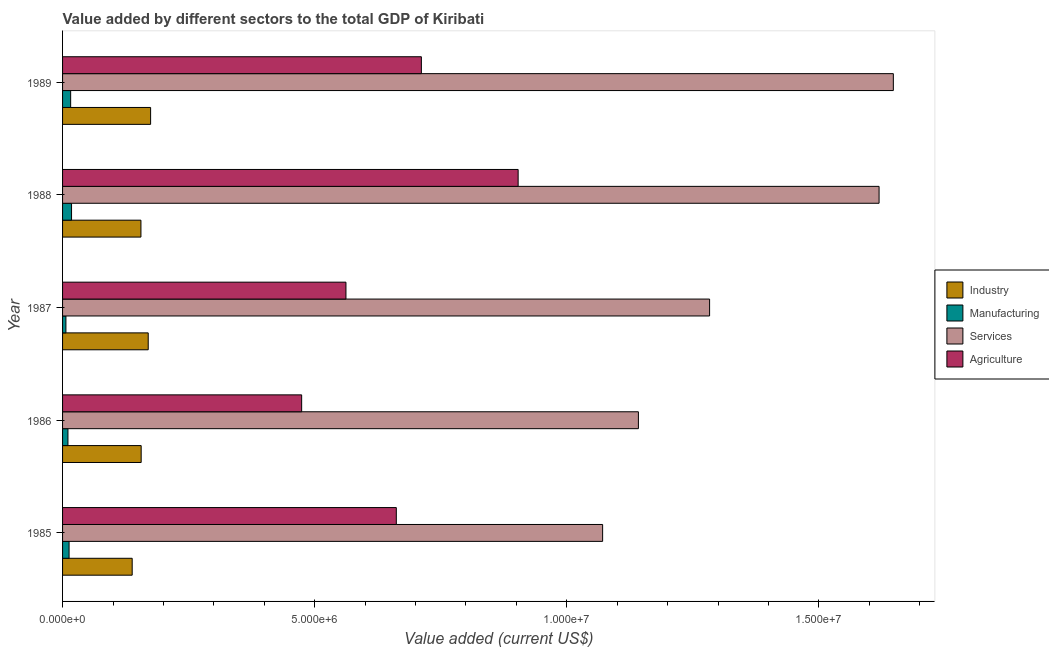How many bars are there on the 1st tick from the top?
Keep it short and to the point. 4. How many bars are there on the 5th tick from the bottom?
Make the answer very short. 4. What is the value added by manufacturing sector in 1989?
Keep it short and to the point. 1.61e+05. Across all years, what is the maximum value added by services sector?
Ensure brevity in your answer.  1.65e+07. Across all years, what is the minimum value added by services sector?
Keep it short and to the point. 1.07e+07. In which year was the value added by agricultural sector maximum?
Ensure brevity in your answer.  1988. What is the total value added by agricultural sector in the graph?
Your answer should be very brief. 3.31e+07. What is the difference between the value added by manufacturing sector in 1987 and that in 1988?
Your response must be concise. -1.12e+05. What is the difference between the value added by agricultural sector in 1988 and the value added by industrial sector in 1985?
Offer a very short reply. 7.65e+06. What is the average value added by agricultural sector per year?
Your answer should be very brief. 6.63e+06. In the year 1987, what is the difference between the value added by manufacturing sector and value added by industrial sector?
Offer a terse response. -1.63e+06. In how many years, is the value added by agricultural sector greater than 3000000 US$?
Your answer should be compact. 5. What is the ratio of the value added by services sector in 1985 to that in 1989?
Provide a succinct answer. 0.65. Is the difference between the value added by services sector in 1986 and 1989 greater than the difference between the value added by agricultural sector in 1986 and 1989?
Offer a terse response. No. What is the difference between the highest and the second highest value added by manufacturing sector?
Keep it short and to the point. 1.76e+04. What is the difference between the highest and the lowest value added by services sector?
Give a very brief answer. 5.77e+06. In how many years, is the value added by industrial sector greater than the average value added by industrial sector taken over all years?
Offer a very short reply. 2. Is the sum of the value added by manufacturing sector in 1985 and 1988 greater than the maximum value added by agricultural sector across all years?
Your response must be concise. No. Is it the case that in every year, the sum of the value added by agricultural sector and value added by services sector is greater than the sum of value added by industrial sector and value added by manufacturing sector?
Your answer should be very brief. Yes. What does the 1st bar from the top in 1988 represents?
Provide a succinct answer. Agriculture. What does the 2nd bar from the bottom in 1989 represents?
Offer a very short reply. Manufacturing. How many bars are there?
Your answer should be compact. 20. How many years are there in the graph?
Make the answer very short. 5. Are the values on the major ticks of X-axis written in scientific E-notation?
Give a very brief answer. Yes. Does the graph contain any zero values?
Give a very brief answer. No. Does the graph contain grids?
Offer a very short reply. No. Where does the legend appear in the graph?
Keep it short and to the point. Center right. How many legend labels are there?
Provide a short and direct response. 4. How are the legend labels stacked?
Ensure brevity in your answer.  Vertical. What is the title of the graph?
Your response must be concise. Value added by different sectors to the total GDP of Kiribati. Does "France" appear as one of the legend labels in the graph?
Your response must be concise. No. What is the label or title of the X-axis?
Offer a very short reply. Value added (current US$). What is the label or title of the Y-axis?
Provide a succinct answer. Year. What is the Value added (current US$) in Industry in 1985?
Keep it short and to the point. 1.38e+06. What is the Value added (current US$) in Manufacturing in 1985?
Provide a short and direct response. 1.29e+05. What is the Value added (current US$) of Services in 1985?
Offer a terse response. 1.07e+07. What is the Value added (current US$) of Agriculture in 1985?
Provide a short and direct response. 6.62e+06. What is the Value added (current US$) of Industry in 1986?
Your answer should be compact. 1.56e+06. What is the Value added (current US$) of Manufacturing in 1986?
Give a very brief answer. 1.07e+05. What is the Value added (current US$) in Services in 1986?
Ensure brevity in your answer.  1.14e+07. What is the Value added (current US$) of Agriculture in 1986?
Offer a terse response. 4.74e+06. What is the Value added (current US$) of Industry in 1987?
Keep it short and to the point. 1.70e+06. What is the Value added (current US$) of Manufacturing in 1987?
Keep it short and to the point. 6.65e+04. What is the Value added (current US$) of Services in 1987?
Keep it short and to the point. 1.28e+07. What is the Value added (current US$) in Agriculture in 1987?
Provide a short and direct response. 5.62e+06. What is the Value added (current US$) of Industry in 1988?
Your response must be concise. 1.55e+06. What is the Value added (current US$) in Manufacturing in 1988?
Ensure brevity in your answer.  1.78e+05. What is the Value added (current US$) of Services in 1988?
Your answer should be very brief. 1.62e+07. What is the Value added (current US$) of Agriculture in 1988?
Provide a succinct answer. 9.03e+06. What is the Value added (current US$) of Industry in 1989?
Your answer should be compact. 1.75e+06. What is the Value added (current US$) in Manufacturing in 1989?
Keep it short and to the point. 1.61e+05. What is the Value added (current US$) in Services in 1989?
Ensure brevity in your answer.  1.65e+07. What is the Value added (current US$) of Agriculture in 1989?
Your response must be concise. 7.12e+06. Across all years, what is the maximum Value added (current US$) of Industry?
Give a very brief answer. 1.75e+06. Across all years, what is the maximum Value added (current US$) in Manufacturing?
Your answer should be compact. 1.78e+05. Across all years, what is the maximum Value added (current US$) in Services?
Give a very brief answer. 1.65e+07. Across all years, what is the maximum Value added (current US$) in Agriculture?
Offer a very short reply. 9.03e+06. Across all years, what is the minimum Value added (current US$) in Industry?
Provide a short and direct response. 1.38e+06. Across all years, what is the minimum Value added (current US$) of Manufacturing?
Your response must be concise. 6.65e+04. Across all years, what is the minimum Value added (current US$) of Services?
Your response must be concise. 1.07e+07. Across all years, what is the minimum Value added (current US$) in Agriculture?
Provide a succinct answer. 4.74e+06. What is the total Value added (current US$) of Industry in the graph?
Your answer should be compact. 7.94e+06. What is the total Value added (current US$) in Manufacturing in the graph?
Provide a succinct answer. 6.41e+05. What is the total Value added (current US$) in Services in the graph?
Give a very brief answer. 6.76e+07. What is the total Value added (current US$) in Agriculture in the graph?
Keep it short and to the point. 3.31e+07. What is the difference between the Value added (current US$) of Industry in 1985 and that in 1986?
Your answer should be compact. -1.78e+05. What is the difference between the Value added (current US$) in Manufacturing in 1985 and that in 1986?
Your answer should be compact. 2.22e+04. What is the difference between the Value added (current US$) in Services in 1985 and that in 1986?
Ensure brevity in your answer.  -7.10e+05. What is the difference between the Value added (current US$) in Agriculture in 1985 and that in 1986?
Your response must be concise. 1.88e+06. What is the difference between the Value added (current US$) of Industry in 1985 and that in 1987?
Make the answer very short. -3.18e+05. What is the difference between the Value added (current US$) of Manufacturing in 1985 and that in 1987?
Provide a short and direct response. 6.27e+04. What is the difference between the Value added (current US$) of Services in 1985 and that in 1987?
Offer a very short reply. -2.12e+06. What is the difference between the Value added (current US$) of Agriculture in 1985 and that in 1987?
Make the answer very short. 9.99e+05. What is the difference between the Value added (current US$) of Industry in 1985 and that in 1988?
Offer a terse response. -1.73e+05. What is the difference between the Value added (current US$) of Manufacturing in 1985 and that in 1988?
Your response must be concise. -4.89e+04. What is the difference between the Value added (current US$) of Services in 1985 and that in 1988?
Offer a terse response. -5.48e+06. What is the difference between the Value added (current US$) of Agriculture in 1985 and that in 1988?
Give a very brief answer. -2.42e+06. What is the difference between the Value added (current US$) of Industry in 1985 and that in 1989?
Your answer should be compact. -3.65e+05. What is the difference between the Value added (current US$) in Manufacturing in 1985 and that in 1989?
Provide a short and direct response. -3.13e+04. What is the difference between the Value added (current US$) in Services in 1985 and that in 1989?
Keep it short and to the point. -5.77e+06. What is the difference between the Value added (current US$) in Agriculture in 1985 and that in 1989?
Your response must be concise. -4.97e+05. What is the difference between the Value added (current US$) in Industry in 1986 and that in 1987?
Your response must be concise. -1.40e+05. What is the difference between the Value added (current US$) of Manufacturing in 1986 and that in 1987?
Your answer should be very brief. 4.04e+04. What is the difference between the Value added (current US$) in Services in 1986 and that in 1987?
Provide a short and direct response. -1.41e+06. What is the difference between the Value added (current US$) in Agriculture in 1986 and that in 1987?
Ensure brevity in your answer.  -8.78e+05. What is the difference between the Value added (current US$) of Industry in 1986 and that in 1988?
Your answer should be compact. 4795.87. What is the difference between the Value added (current US$) in Manufacturing in 1986 and that in 1988?
Your answer should be very brief. -7.12e+04. What is the difference between the Value added (current US$) of Services in 1986 and that in 1988?
Your answer should be compact. -4.77e+06. What is the difference between the Value added (current US$) in Agriculture in 1986 and that in 1988?
Offer a terse response. -4.29e+06. What is the difference between the Value added (current US$) of Industry in 1986 and that in 1989?
Your response must be concise. -1.87e+05. What is the difference between the Value added (current US$) of Manufacturing in 1986 and that in 1989?
Provide a short and direct response. -5.36e+04. What is the difference between the Value added (current US$) of Services in 1986 and that in 1989?
Your answer should be compact. -5.06e+06. What is the difference between the Value added (current US$) in Agriculture in 1986 and that in 1989?
Offer a very short reply. -2.37e+06. What is the difference between the Value added (current US$) of Industry in 1987 and that in 1988?
Make the answer very short. 1.45e+05. What is the difference between the Value added (current US$) in Manufacturing in 1987 and that in 1988?
Make the answer very short. -1.12e+05. What is the difference between the Value added (current US$) of Services in 1987 and that in 1988?
Provide a short and direct response. -3.36e+06. What is the difference between the Value added (current US$) of Agriculture in 1987 and that in 1988?
Your answer should be compact. -3.41e+06. What is the difference between the Value added (current US$) of Industry in 1987 and that in 1989?
Your answer should be compact. -4.74e+04. What is the difference between the Value added (current US$) of Manufacturing in 1987 and that in 1989?
Provide a short and direct response. -9.40e+04. What is the difference between the Value added (current US$) in Services in 1987 and that in 1989?
Ensure brevity in your answer.  -3.64e+06. What is the difference between the Value added (current US$) of Agriculture in 1987 and that in 1989?
Your response must be concise. -1.50e+06. What is the difference between the Value added (current US$) in Industry in 1988 and that in 1989?
Your answer should be compact. -1.92e+05. What is the difference between the Value added (current US$) of Manufacturing in 1988 and that in 1989?
Give a very brief answer. 1.76e+04. What is the difference between the Value added (current US$) in Services in 1988 and that in 1989?
Make the answer very short. -2.83e+05. What is the difference between the Value added (current US$) of Agriculture in 1988 and that in 1989?
Provide a succinct answer. 1.92e+06. What is the difference between the Value added (current US$) in Industry in 1985 and the Value added (current US$) in Manufacturing in 1986?
Offer a very short reply. 1.27e+06. What is the difference between the Value added (current US$) in Industry in 1985 and the Value added (current US$) in Services in 1986?
Your response must be concise. -1.00e+07. What is the difference between the Value added (current US$) in Industry in 1985 and the Value added (current US$) in Agriculture in 1986?
Provide a short and direct response. -3.36e+06. What is the difference between the Value added (current US$) of Manufacturing in 1985 and the Value added (current US$) of Services in 1986?
Offer a terse response. -1.13e+07. What is the difference between the Value added (current US$) of Manufacturing in 1985 and the Value added (current US$) of Agriculture in 1986?
Provide a short and direct response. -4.61e+06. What is the difference between the Value added (current US$) of Services in 1985 and the Value added (current US$) of Agriculture in 1986?
Keep it short and to the point. 5.97e+06. What is the difference between the Value added (current US$) of Industry in 1985 and the Value added (current US$) of Manufacturing in 1987?
Provide a succinct answer. 1.31e+06. What is the difference between the Value added (current US$) in Industry in 1985 and the Value added (current US$) in Services in 1987?
Your answer should be very brief. -1.15e+07. What is the difference between the Value added (current US$) of Industry in 1985 and the Value added (current US$) of Agriculture in 1987?
Your answer should be compact. -4.24e+06. What is the difference between the Value added (current US$) of Manufacturing in 1985 and the Value added (current US$) of Services in 1987?
Your response must be concise. -1.27e+07. What is the difference between the Value added (current US$) of Manufacturing in 1985 and the Value added (current US$) of Agriculture in 1987?
Make the answer very short. -5.49e+06. What is the difference between the Value added (current US$) of Services in 1985 and the Value added (current US$) of Agriculture in 1987?
Your response must be concise. 5.09e+06. What is the difference between the Value added (current US$) in Industry in 1985 and the Value added (current US$) in Manufacturing in 1988?
Provide a succinct answer. 1.20e+06. What is the difference between the Value added (current US$) in Industry in 1985 and the Value added (current US$) in Services in 1988?
Your response must be concise. -1.48e+07. What is the difference between the Value added (current US$) in Industry in 1985 and the Value added (current US$) in Agriculture in 1988?
Ensure brevity in your answer.  -7.65e+06. What is the difference between the Value added (current US$) in Manufacturing in 1985 and the Value added (current US$) in Services in 1988?
Your answer should be very brief. -1.61e+07. What is the difference between the Value added (current US$) in Manufacturing in 1985 and the Value added (current US$) in Agriculture in 1988?
Give a very brief answer. -8.91e+06. What is the difference between the Value added (current US$) of Services in 1985 and the Value added (current US$) of Agriculture in 1988?
Keep it short and to the point. 1.68e+06. What is the difference between the Value added (current US$) of Industry in 1985 and the Value added (current US$) of Manufacturing in 1989?
Your response must be concise. 1.22e+06. What is the difference between the Value added (current US$) of Industry in 1985 and the Value added (current US$) of Services in 1989?
Provide a short and direct response. -1.51e+07. What is the difference between the Value added (current US$) in Industry in 1985 and the Value added (current US$) in Agriculture in 1989?
Give a very brief answer. -5.73e+06. What is the difference between the Value added (current US$) of Manufacturing in 1985 and the Value added (current US$) of Services in 1989?
Give a very brief answer. -1.63e+07. What is the difference between the Value added (current US$) in Manufacturing in 1985 and the Value added (current US$) in Agriculture in 1989?
Make the answer very short. -6.99e+06. What is the difference between the Value added (current US$) in Services in 1985 and the Value added (current US$) in Agriculture in 1989?
Provide a succinct answer. 3.59e+06. What is the difference between the Value added (current US$) in Industry in 1986 and the Value added (current US$) in Manufacturing in 1987?
Provide a short and direct response. 1.49e+06. What is the difference between the Value added (current US$) of Industry in 1986 and the Value added (current US$) of Services in 1987?
Ensure brevity in your answer.  -1.13e+07. What is the difference between the Value added (current US$) of Industry in 1986 and the Value added (current US$) of Agriculture in 1987?
Provide a short and direct response. -4.06e+06. What is the difference between the Value added (current US$) of Manufacturing in 1986 and the Value added (current US$) of Services in 1987?
Your response must be concise. -1.27e+07. What is the difference between the Value added (current US$) of Manufacturing in 1986 and the Value added (current US$) of Agriculture in 1987?
Give a very brief answer. -5.51e+06. What is the difference between the Value added (current US$) in Services in 1986 and the Value added (current US$) in Agriculture in 1987?
Offer a very short reply. 5.80e+06. What is the difference between the Value added (current US$) of Industry in 1986 and the Value added (current US$) of Manufacturing in 1988?
Ensure brevity in your answer.  1.38e+06. What is the difference between the Value added (current US$) of Industry in 1986 and the Value added (current US$) of Services in 1988?
Your answer should be compact. -1.46e+07. What is the difference between the Value added (current US$) in Industry in 1986 and the Value added (current US$) in Agriculture in 1988?
Offer a very short reply. -7.48e+06. What is the difference between the Value added (current US$) of Manufacturing in 1986 and the Value added (current US$) of Services in 1988?
Make the answer very short. -1.61e+07. What is the difference between the Value added (current US$) in Manufacturing in 1986 and the Value added (current US$) in Agriculture in 1988?
Your answer should be very brief. -8.93e+06. What is the difference between the Value added (current US$) in Services in 1986 and the Value added (current US$) in Agriculture in 1988?
Offer a very short reply. 2.38e+06. What is the difference between the Value added (current US$) of Industry in 1986 and the Value added (current US$) of Manufacturing in 1989?
Your response must be concise. 1.40e+06. What is the difference between the Value added (current US$) of Industry in 1986 and the Value added (current US$) of Services in 1989?
Provide a short and direct response. -1.49e+07. What is the difference between the Value added (current US$) in Industry in 1986 and the Value added (current US$) in Agriculture in 1989?
Your answer should be compact. -5.56e+06. What is the difference between the Value added (current US$) in Manufacturing in 1986 and the Value added (current US$) in Services in 1989?
Your answer should be very brief. -1.64e+07. What is the difference between the Value added (current US$) of Manufacturing in 1986 and the Value added (current US$) of Agriculture in 1989?
Offer a terse response. -7.01e+06. What is the difference between the Value added (current US$) of Services in 1986 and the Value added (current US$) of Agriculture in 1989?
Your answer should be compact. 4.30e+06. What is the difference between the Value added (current US$) in Industry in 1987 and the Value added (current US$) in Manufacturing in 1988?
Make the answer very short. 1.52e+06. What is the difference between the Value added (current US$) of Industry in 1987 and the Value added (current US$) of Services in 1988?
Your answer should be very brief. -1.45e+07. What is the difference between the Value added (current US$) in Industry in 1987 and the Value added (current US$) in Agriculture in 1988?
Keep it short and to the point. -7.34e+06. What is the difference between the Value added (current US$) in Manufacturing in 1987 and the Value added (current US$) in Services in 1988?
Ensure brevity in your answer.  -1.61e+07. What is the difference between the Value added (current US$) in Manufacturing in 1987 and the Value added (current US$) in Agriculture in 1988?
Offer a very short reply. -8.97e+06. What is the difference between the Value added (current US$) in Services in 1987 and the Value added (current US$) in Agriculture in 1988?
Ensure brevity in your answer.  3.80e+06. What is the difference between the Value added (current US$) of Industry in 1987 and the Value added (current US$) of Manufacturing in 1989?
Offer a very short reply. 1.54e+06. What is the difference between the Value added (current US$) of Industry in 1987 and the Value added (current US$) of Services in 1989?
Your answer should be compact. -1.48e+07. What is the difference between the Value added (current US$) in Industry in 1987 and the Value added (current US$) in Agriculture in 1989?
Your answer should be very brief. -5.42e+06. What is the difference between the Value added (current US$) of Manufacturing in 1987 and the Value added (current US$) of Services in 1989?
Your response must be concise. -1.64e+07. What is the difference between the Value added (current US$) in Manufacturing in 1987 and the Value added (current US$) in Agriculture in 1989?
Offer a terse response. -7.05e+06. What is the difference between the Value added (current US$) in Services in 1987 and the Value added (current US$) in Agriculture in 1989?
Give a very brief answer. 5.72e+06. What is the difference between the Value added (current US$) in Industry in 1988 and the Value added (current US$) in Manufacturing in 1989?
Provide a short and direct response. 1.39e+06. What is the difference between the Value added (current US$) of Industry in 1988 and the Value added (current US$) of Services in 1989?
Your answer should be compact. -1.49e+07. What is the difference between the Value added (current US$) of Industry in 1988 and the Value added (current US$) of Agriculture in 1989?
Ensure brevity in your answer.  -5.56e+06. What is the difference between the Value added (current US$) in Manufacturing in 1988 and the Value added (current US$) in Services in 1989?
Provide a short and direct response. -1.63e+07. What is the difference between the Value added (current US$) of Manufacturing in 1988 and the Value added (current US$) of Agriculture in 1989?
Keep it short and to the point. -6.94e+06. What is the difference between the Value added (current US$) in Services in 1988 and the Value added (current US$) in Agriculture in 1989?
Your answer should be very brief. 9.08e+06. What is the average Value added (current US$) in Industry per year?
Your answer should be compact. 1.59e+06. What is the average Value added (current US$) of Manufacturing per year?
Offer a very short reply. 1.28e+05. What is the average Value added (current US$) in Services per year?
Make the answer very short. 1.35e+07. What is the average Value added (current US$) in Agriculture per year?
Provide a short and direct response. 6.63e+06. In the year 1985, what is the difference between the Value added (current US$) of Industry and Value added (current US$) of Manufacturing?
Keep it short and to the point. 1.25e+06. In the year 1985, what is the difference between the Value added (current US$) in Industry and Value added (current US$) in Services?
Offer a very short reply. -9.33e+06. In the year 1985, what is the difference between the Value added (current US$) of Industry and Value added (current US$) of Agriculture?
Your answer should be compact. -5.24e+06. In the year 1985, what is the difference between the Value added (current US$) in Manufacturing and Value added (current US$) in Services?
Provide a succinct answer. -1.06e+07. In the year 1985, what is the difference between the Value added (current US$) of Manufacturing and Value added (current US$) of Agriculture?
Make the answer very short. -6.49e+06. In the year 1985, what is the difference between the Value added (current US$) in Services and Value added (current US$) in Agriculture?
Make the answer very short. 4.09e+06. In the year 1986, what is the difference between the Value added (current US$) in Industry and Value added (current US$) in Manufacturing?
Your answer should be compact. 1.45e+06. In the year 1986, what is the difference between the Value added (current US$) of Industry and Value added (current US$) of Services?
Make the answer very short. -9.86e+06. In the year 1986, what is the difference between the Value added (current US$) in Industry and Value added (current US$) in Agriculture?
Your answer should be very brief. -3.18e+06. In the year 1986, what is the difference between the Value added (current US$) of Manufacturing and Value added (current US$) of Services?
Your response must be concise. -1.13e+07. In the year 1986, what is the difference between the Value added (current US$) in Manufacturing and Value added (current US$) in Agriculture?
Keep it short and to the point. -4.63e+06. In the year 1986, what is the difference between the Value added (current US$) in Services and Value added (current US$) in Agriculture?
Offer a very short reply. 6.68e+06. In the year 1987, what is the difference between the Value added (current US$) in Industry and Value added (current US$) in Manufacturing?
Your answer should be very brief. 1.63e+06. In the year 1987, what is the difference between the Value added (current US$) in Industry and Value added (current US$) in Services?
Offer a very short reply. -1.11e+07. In the year 1987, what is the difference between the Value added (current US$) of Industry and Value added (current US$) of Agriculture?
Your answer should be very brief. -3.92e+06. In the year 1987, what is the difference between the Value added (current US$) of Manufacturing and Value added (current US$) of Services?
Make the answer very short. -1.28e+07. In the year 1987, what is the difference between the Value added (current US$) in Manufacturing and Value added (current US$) in Agriculture?
Your answer should be compact. -5.55e+06. In the year 1987, what is the difference between the Value added (current US$) in Services and Value added (current US$) in Agriculture?
Your response must be concise. 7.21e+06. In the year 1988, what is the difference between the Value added (current US$) in Industry and Value added (current US$) in Manufacturing?
Make the answer very short. 1.38e+06. In the year 1988, what is the difference between the Value added (current US$) in Industry and Value added (current US$) in Services?
Make the answer very short. -1.46e+07. In the year 1988, what is the difference between the Value added (current US$) of Industry and Value added (current US$) of Agriculture?
Keep it short and to the point. -7.48e+06. In the year 1988, what is the difference between the Value added (current US$) of Manufacturing and Value added (current US$) of Services?
Provide a short and direct response. -1.60e+07. In the year 1988, what is the difference between the Value added (current US$) of Manufacturing and Value added (current US$) of Agriculture?
Provide a short and direct response. -8.86e+06. In the year 1988, what is the difference between the Value added (current US$) of Services and Value added (current US$) of Agriculture?
Make the answer very short. 7.16e+06. In the year 1989, what is the difference between the Value added (current US$) of Industry and Value added (current US$) of Manufacturing?
Your answer should be very brief. 1.59e+06. In the year 1989, what is the difference between the Value added (current US$) in Industry and Value added (current US$) in Services?
Your answer should be compact. -1.47e+07. In the year 1989, what is the difference between the Value added (current US$) in Industry and Value added (current US$) in Agriculture?
Offer a terse response. -5.37e+06. In the year 1989, what is the difference between the Value added (current US$) of Manufacturing and Value added (current US$) of Services?
Your answer should be compact. -1.63e+07. In the year 1989, what is the difference between the Value added (current US$) of Manufacturing and Value added (current US$) of Agriculture?
Your answer should be very brief. -6.95e+06. In the year 1989, what is the difference between the Value added (current US$) of Services and Value added (current US$) of Agriculture?
Ensure brevity in your answer.  9.36e+06. What is the ratio of the Value added (current US$) in Industry in 1985 to that in 1986?
Make the answer very short. 0.89. What is the ratio of the Value added (current US$) in Manufacturing in 1985 to that in 1986?
Provide a succinct answer. 1.21. What is the ratio of the Value added (current US$) of Services in 1985 to that in 1986?
Your response must be concise. 0.94. What is the ratio of the Value added (current US$) of Agriculture in 1985 to that in 1986?
Your answer should be compact. 1.4. What is the ratio of the Value added (current US$) of Industry in 1985 to that in 1987?
Give a very brief answer. 0.81. What is the ratio of the Value added (current US$) in Manufacturing in 1985 to that in 1987?
Give a very brief answer. 1.94. What is the ratio of the Value added (current US$) in Services in 1985 to that in 1987?
Your answer should be very brief. 0.83. What is the ratio of the Value added (current US$) in Agriculture in 1985 to that in 1987?
Provide a short and direct response. 1.18. What is the ratio of the Value added (current US$) in Industry in 1985 to that in 1988?
Provide a short and direct response. 0.89. What is the ratio of the Value added (current US$) of Manufacturing in 1985 to that in 1988?
Offer a terse response. 0.73. What is the ratio of the Value added (current US$) of Services in 1985 to that in 1988?
Your answer should be very brief. 0.66. What is the ratio of the Value added (current US$) of Agriculture in 1985 to that in 1988?
Your answer should be very brief. 0.73. What is the ratio of the Value added (current US$) in Industry in 1985 to that in 1989?
Your response must be concise. 0.79. What is the ratio of the Value added (current US$) of Manufacturing in 1985 to that in 1989?
Make the answer very short. 0.8. What is the ratio of the Value added (current US$) in Services in 1985 to that in 1989?
Your response must be concise. 0.65. What is the ratio of the Value added (current US$) in Agriculture in 1985 to that in 1989?
Provide a short and direct response. 0.93. What is the ratio of the Value added (current US$) in Industry in 1986 to that in 1987?
Your response must be concise. 0.92. What is the ratio of the Value added (current US$) in Manufacturing in 1986 to that in 1987?
Provide a short and direct response. 1.61. What is the ratio of the Value added (current US$) in Services in 1986 to that in 1987?
Give a very brief answer. 0.89. What is the ratio of the Value added (current US$) in Agriculture in 1986 to that in 1987?
Give a very brief answer. 0.84. What is the ratio of the Value added (current US$) of Industry in 1986 to that in 1988?
Your answer should be compact. 1. What is the ratio of the Value added (current US$) in Manufacturing in 1986 to that in 1988?
Your answer should be compact. 0.6. What is the ratio of the Value added (current US$) in Services in 1986 to that in 1988?
Your answer should be compact. 0.71. What is the ratio of the Value added (current US$) of Agriculture in 1986 to that in 1988?
Offer a terse response. 0.52. What is the ratio of the Value added (current US$) in Industry in 1986 to that in 1989?
Provide a short and direct response. 0.89. What is the ratio of the Value added (current US$) in Manufacturing in 1986 to that in 1989?
Make the answer very short. 0.67. What is the ratio of the Value added (current US$) of Services in 1986 to that in 1989?
Keep it short and to the point. 0.69. What is the ratio of the Value added (current US$) in Agriculture in 1986 to that in 1989?
Your answer should be very brief. 0.67. What is the ratio of the Value added (current US$) of Industry in 1987 to that in 1988?
Make the answer very short. 1.09. What is the ratio of the Value added (current US$) in Manufacturing in 1987 to that in 1988?
Your answer should be very brief. 0.37. What is the ratio of the Value added (current US$) in Services in 1987 to that in 1988?
Provide a short and direct response. 0.79. What is the ratio of the Value added (current US$) of Agriculture in 1987 to that in 1988?
Your answer should be very brief. 0.62. What is the ratio of the Value added (current US$) of Industry in 1987 to that in 1989?
Offer a terse response. 0.97. What is the ratio of the Value added (current US$) of Manufacturing in 1987 to that in 1989?
Your answer should be compact. 0.41. What is the ratio of the Value added (current US$) in Services in 1987 to that in 1989?
Your response must be concise. 0.78. What is the ratio of the Value added (current US$) of Agriculture in 1987 to that in 1989?
Offer a very short reply. 0.79. What is the ratio of the Value added (current US$) of Industry in 1988 to that in 1989?
Offer a terse response. 0.89. What is the ratio of the Value added (current US$) in Manufacturing in 1988 to that in 1989?
Your answer should be compact. 1.11. What is the ratio of the Value added (current US$) in Services in 1988 to that in 1989?
Your answer should be very brief. 0.98. What is the ratio of the Value added (current US$) of Agriculture in 1988 to that in 1989?
Your response must be concise. 1.27. What is the difference between the highest and the second highest Value added (current US$) in Industry?
Give a very brief answer. 4.74e+04. What is the difference between the highest and the second highest Value added (current US$) in Manufacturing?
Provide a short and direct response. 1.76e+04. What is the difference between the highest and the second highest Value added (current US$) of Services?
Provide a succinct answer. 2.83e+05. What is the difference between the highest and the second highest Value added (current US$) in Agriculture?
Your response must be concise. 1.92e+06. What is the difference between the highest and the lowest Value added (current US$) in Industry?
Your answer should be very brief. 3.65e+05. What is the difference between the highest and the lowest Value added (current US$) in Manufacturing?
Make the answer very short. 1.12e+05. What is the difference between the highest and the lowest Value added (current US$) of Services?
Your answer should be very brief. 5.77e+06. What is the difference between the highest and the lowest Value added (current US$) in Agriculture?
Your answer should be very brief. 4.29e+06. 